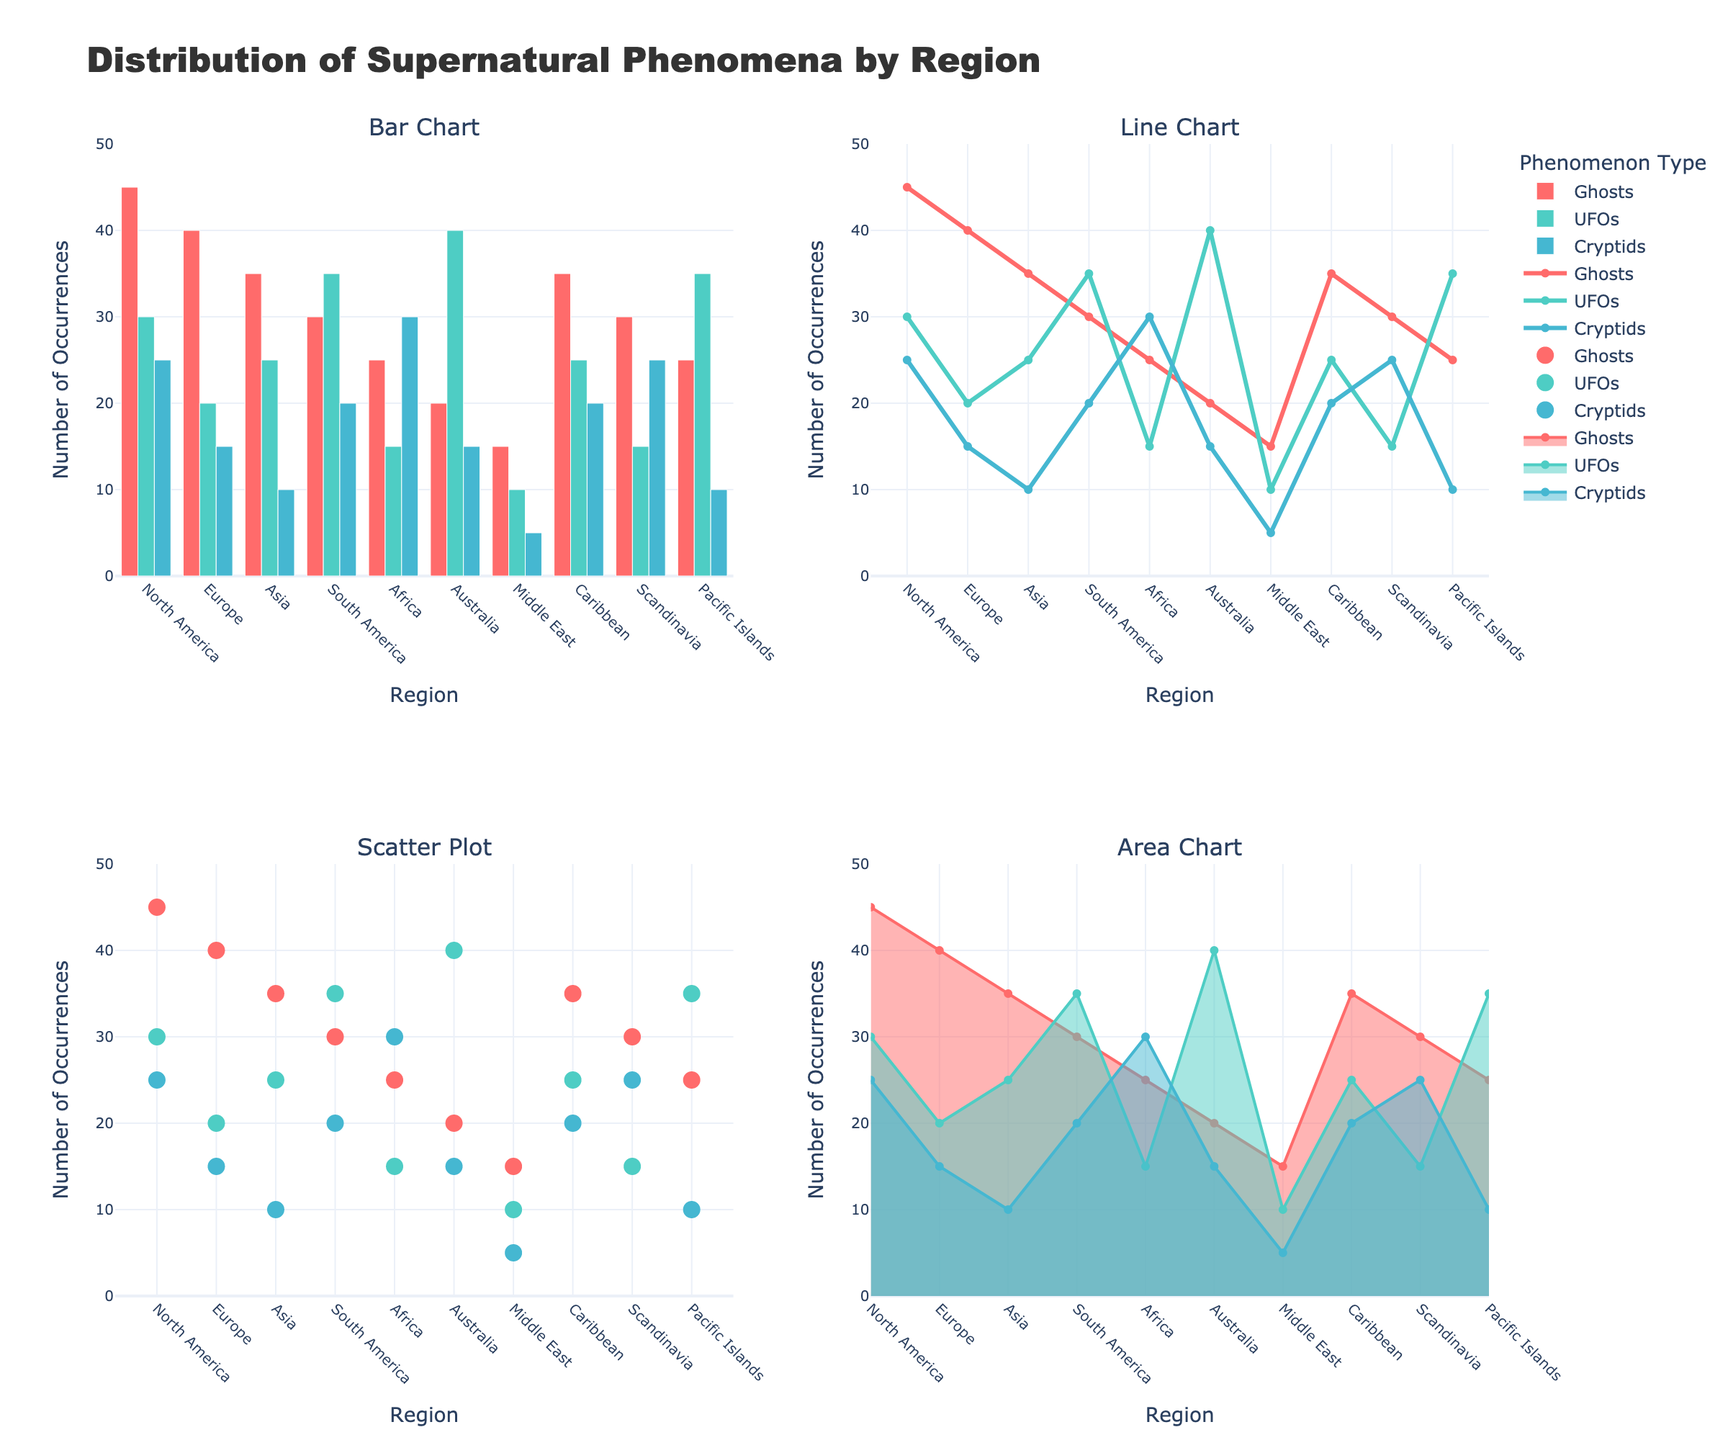What is the title of the figure? The title of the figure is displayed prominently at the top of the plot.
Answer: Pricing Trends for Various Wood Species (2013-2022) How many wood species' pricing trends are shown in the plot? The plot has individual subplots for each wood species, and we can count the subplot titles.
Answer: 5 What color represents the price trend for Oak? By looking at the lines representing each wood species in the plot and matching the color with the Oak subplot, we find the color.
Answer: Brown Which wood species had the lowest price in 2022? Observing the last data point (2022) in the subplots, Pine's marker is visually the lowest.
Answer: Pine Between which two years did Cherry prices increase the most? Looking at Cherry's prices across years and identifying the steepest upward slope between consecutive years reveals the highest increase between 2021 and 2022.
Answer: 2021 and 2022 What is the price of Maple wood in 2017? Locate 2017 on the x-axis of the Maple subplot and find the corresponding y-value.
Answer: $3.40 Which wood species had the highest price in 2015? In 2015, compare the y-values of all subplots and see that Walnut's marker is the highest.
Answer: Walnut By how much did the price of Oak wood increase from 2013 to 2022? Subtract the Oak price in 2013 from its price in 2022 ($4.85 - $3.50).
Answer: $1.35 Is the price trend for Pine wood more stable compared to Walnut wood? Compare the overall consistency of the lines: Pine shows a smoother, more stable trend, while Walnut exhibits steeper increases.
Answer: Yes Which wood species showed a continuous increase in price every year without any drop? Check each subplot to see which wood species' line never dips year-to-year, revealing Maple's price never drops.
Answer: Maple 